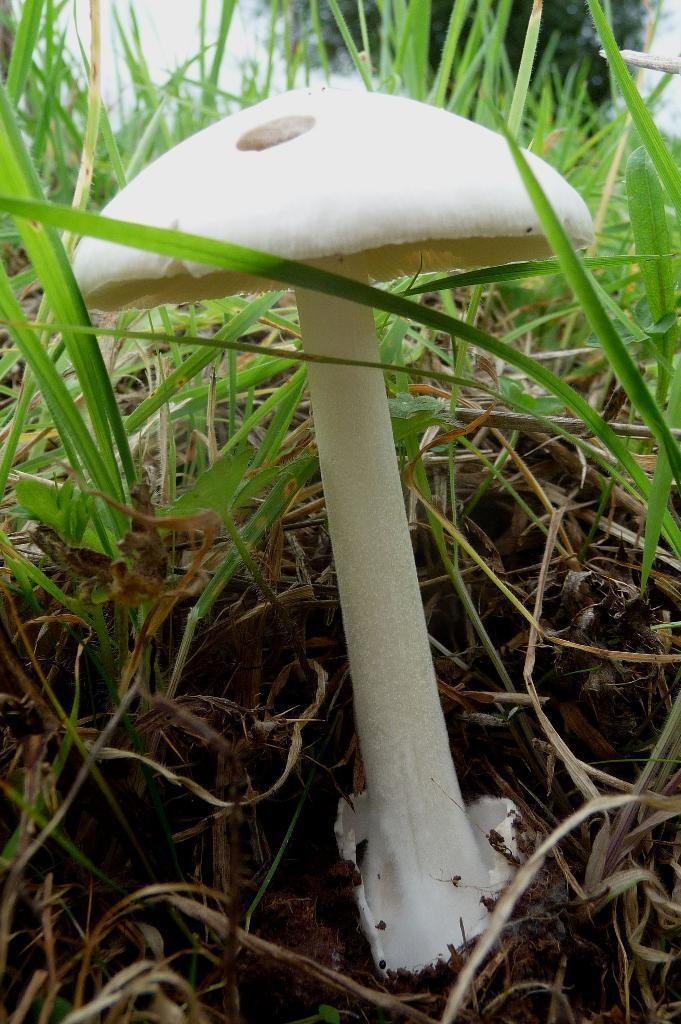What is the main subject of the image? There is a mushroom in the image. What type of vegetation is present on the ground in the image? There is grass on the ground in the image. What can be seen in the background of the image? There is a tree and the sky visible in the background of the image. What type of owl can be seen perched on the tree in the image? There is no owl present in the image; it only features a mushroom, grass, a tree, and the sky. 